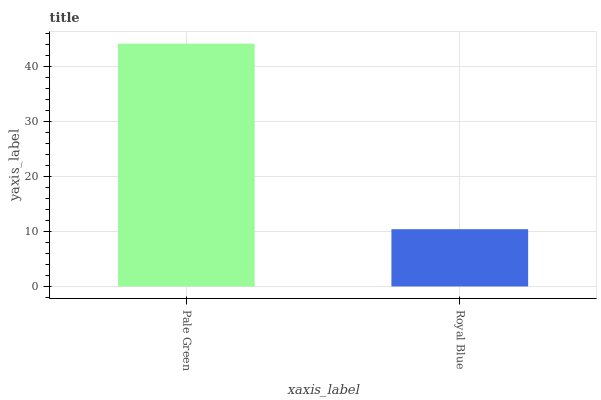Is Royal Blue the minimum?
Answer yes or no. Yes. Is Pale Green the maximum?
Answer yes or no. Yes. Is Royal Blue the maximum?
Answer yes or no. No. Is Pale Green greater than Royal Blue?
Answer yes or no. Yes. Is Royal Blue less than Pale Green?
Answer yes or no. Yes. Is Royal Blue greater than Pale Green?
Answer yes or no. No. Is Pale Green less than Royal Blue?
Answer yes or no. No. Is Pale Green the high median?
Answer yes or no. Yes. Is Royal Blue the low median?
Answer yes or no. Yes. Is Royal Blue the high median?
Answer yes or no. No. Is Pale Green the low median?
Answer yes or no. No. 